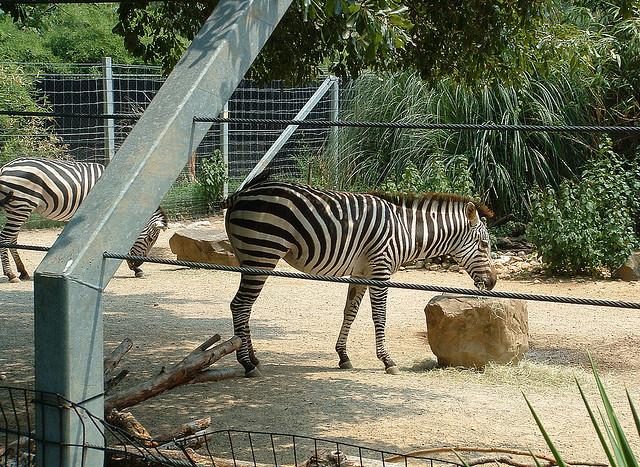How many rocks?
Concise answer only. 2. What is the fence made of?
Keep it brief. Metal. The zebras are in a field?
Be succinct. No. How many zebras are there?
Concise answer only. 2. 